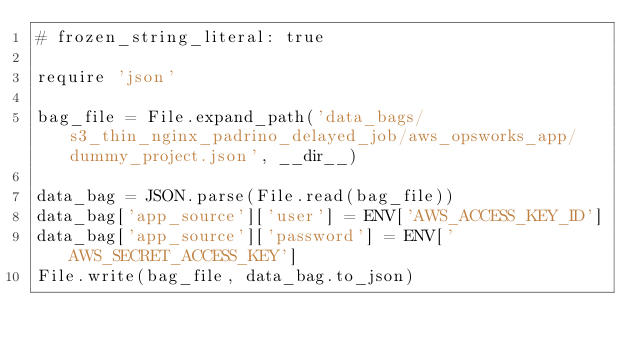<code> <loc_0><loc_0><loc_500><loc_500><_Ruby_># frozen_string_literal: true

require 'json'

bag_file = File.expand_path('data_bags/s3_thin_nginx_padrino_delayed_job/aws_opsworks_app/dummy_project.json', __dir__)

data_bag = JSON.parse(File.read(bag_file))
data_bag['app_source']['user'] = ENV['AWS_ACCESS_KEY_ID']
data_bag['app_source']['password'] = ENV['AWS_SECRET_ACCESS_KEY']
File.write(bag_file, data_bag.to_json)
</code> 